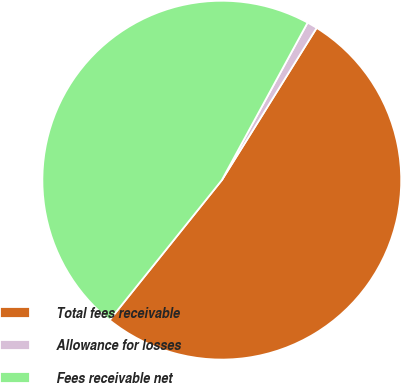Convert chart. <chart><loc_0><loc_0><loc_500><loc_500><pie_chart><fcel>Total fees receivable<fcel>Allowance for losses<fcel>Fees receivable net<nl><fcel>51.89%<fcel>0.93%<fcel>47.18%<nl></chart> 